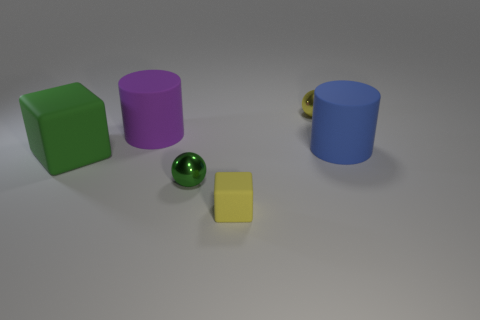Can you tell me something about the lighting and shadows in the image? Certainly! The image has a central light source casting soft shadows under and to the right of the objects. This indicates the light is coming from the top left, which is consistent with the lighter shading on the top and left sides of the objects. Does the lighting have any effect on the colors of the objects? Yes, the lighting accentuates the colors, giving them depth and making them appear more vibrant. It also provides a sense of texture, especially visible on the surfaces facing the light source directly. 